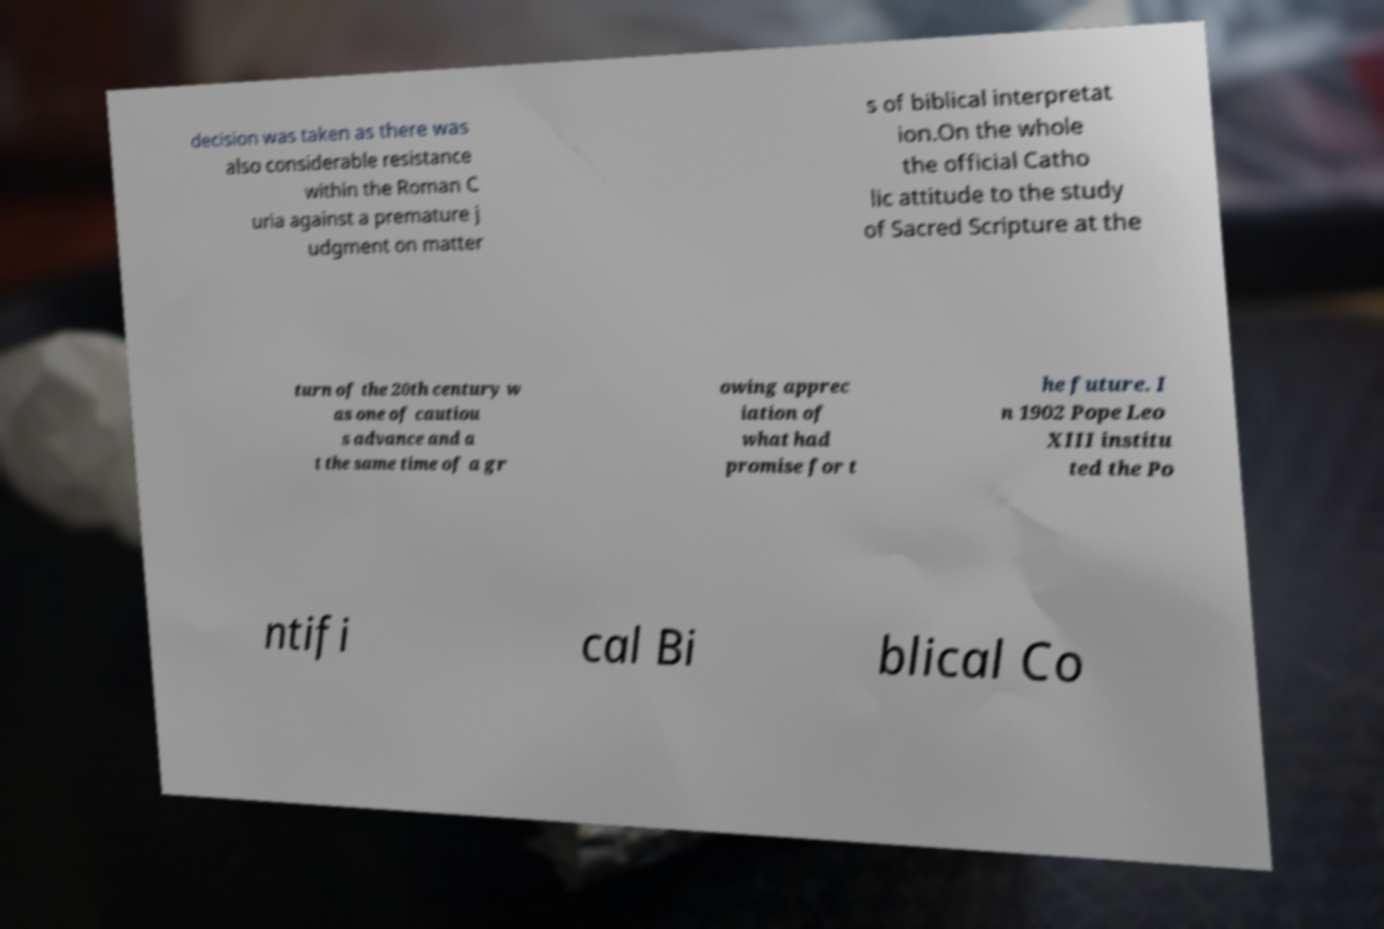Can you read and provide the text displayed in the image?This photo seems to have some interesting text. Can you extract and type it out for me? decision was taken as there was also considerable resistance within the Roman C uria against a premature j udgment on matter s of biblical interpretat ion.On the whole the official Catho lic attitude to the study of Sacred Scripture at the turn of the 20th century w as one of cautiou s advance and a t the same time of a gr owing apprec iation of what had promise for t he future. I n 1902 Pope Leo XIII institu ted the Po ntifi cal Bi blical Co 